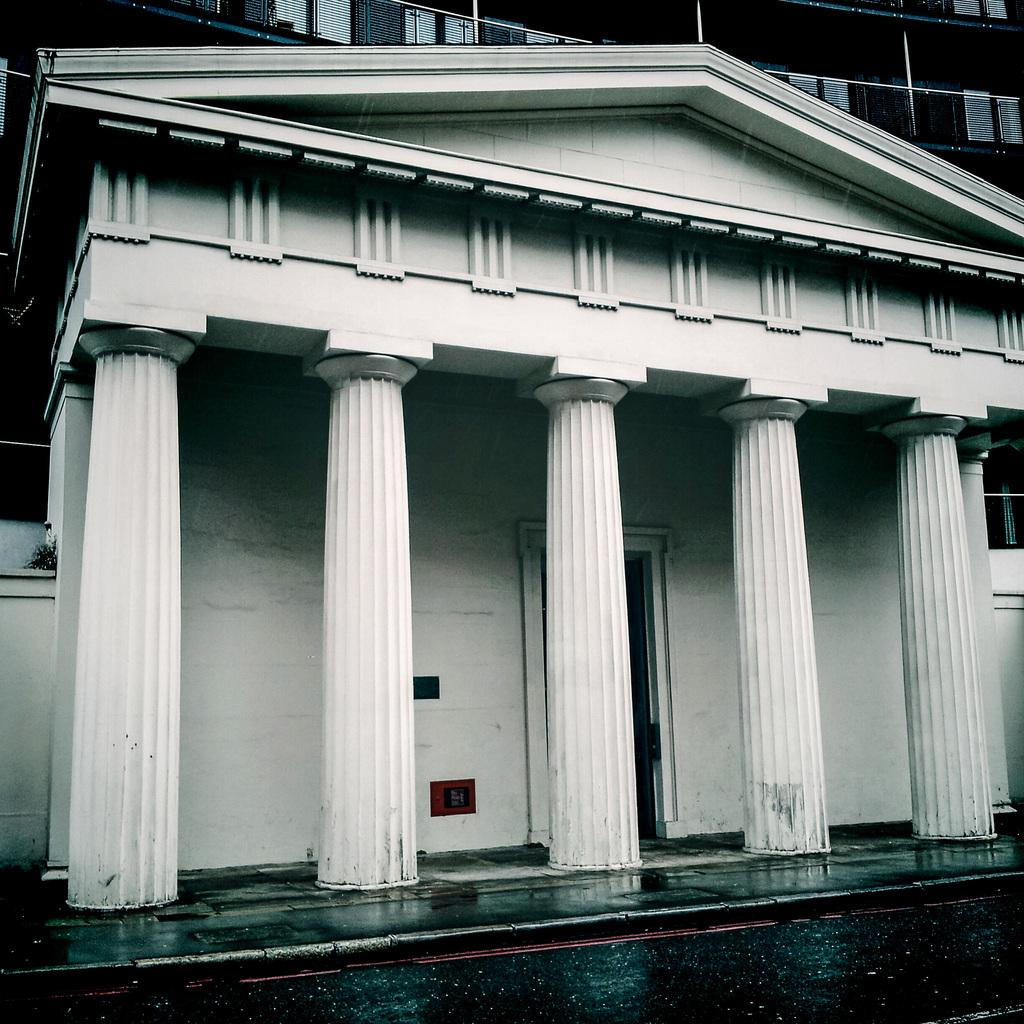What type of pathway is visible in the image? There is a road in the image. What architectural elements can be seen in the image? There are pillars and a wall visible in the image. What structure is present in the background of the image? There is a building with windows in the background of the image. What type of pancake is being served at the government meeting in the image? There is no government meeting or pancake present in the image. 